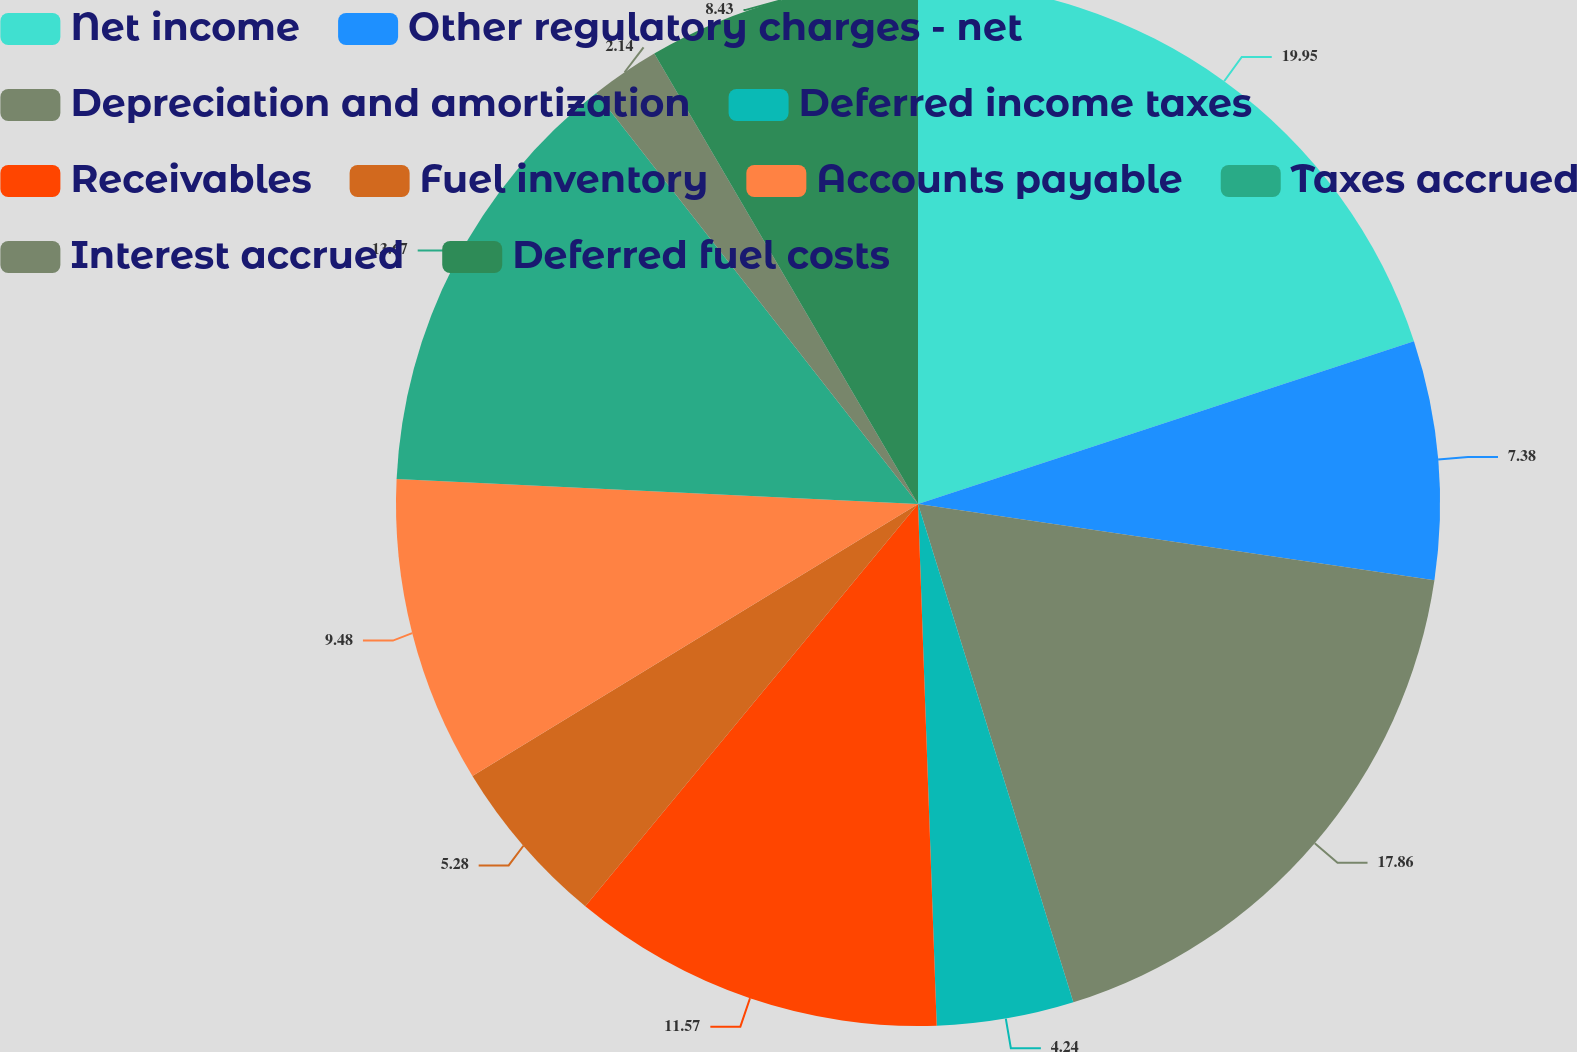<chart> <loc_0><loc_0><loc_500><loc_500><pie_chart><fcel>Net income<fcel>Other regulatory charges - net<fcel>Depreciation and amortization<fcel>Deferred income taxes<fcel>Receivables<fcel>Fuel inventory<fcel>Accounts payable<fcel>Taxes accrued<fcel>Interest accrued<fcel>Deferred fuel costs<nl><fcel>19.95%<fcel>7.38%<fcel>17.86%<fcel>4.24%<fcel>11.57%<fcel>5.28%<fcel>9.48%<fcel>13.67%<fcel>2.14%<fcel>8.43%<nl></chart> 